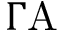<formula> <loc_0><loc_0><loc_500><loc_500>\Gamma A</formula> 